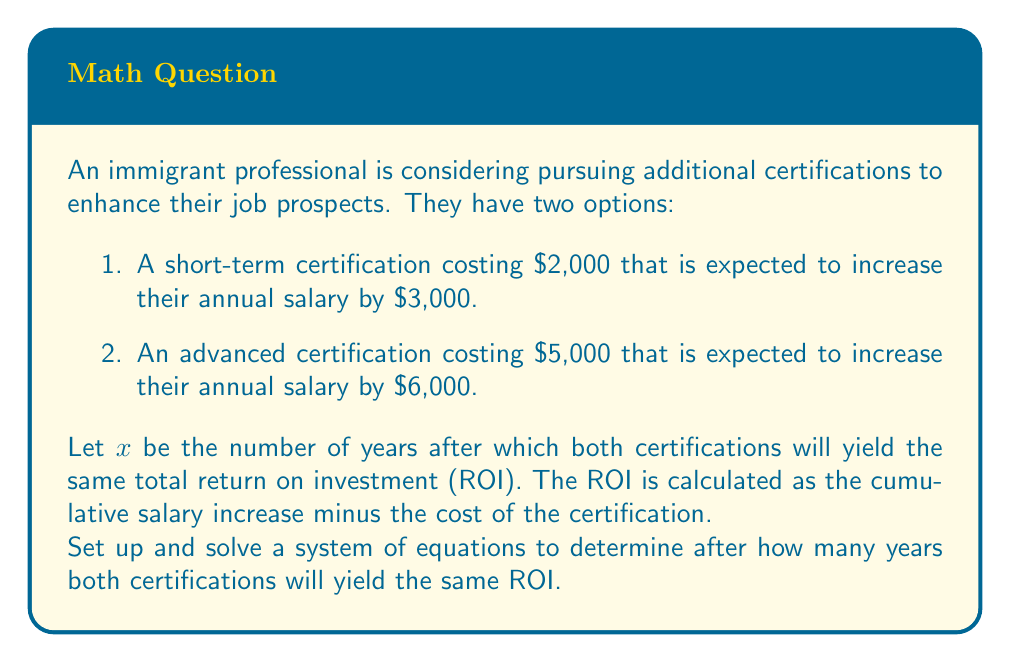What is the answer to this math problem? Let's approach this step-by-step:

1) First, let's define our equations. For each certification, the ROI after $x$ years will be:

   Short-term certification: $3000x - 2000$
   Advanced certification: $6000x - 5000$

2) For these to be equal:

   $$3000x - 2000 = 6000x - 5000$$

3) Now we have our equation. Let's solve it:

   $$3000x - 2000 = 6000x - 5000$$
   $$-3000x = -3000$$
   $$x = 1$$

4) To verify, let's calculate the ROI for both certifications after 1 year:

   Short-term: $3000(1) - 2000 = 1000$
   Advanced: $6000(1) - 5000 = 1000$

5) Indeed, after 1 year, both certifications yield the same ROI of $1000.

6) It's worth noting that after this point, the advanced certification will yield a higher ROI due to its higher annual salary increase.
Answer: $x = 1$ year 